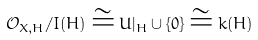Convert formula to latex. <formula><loc_0><loc_0><loc_500><loc_500>\mathcal { O } _ { X , H } / I ( H ) \cong U | _ { H } \cup \{ 0 \} \cong k ( H )</formula> 